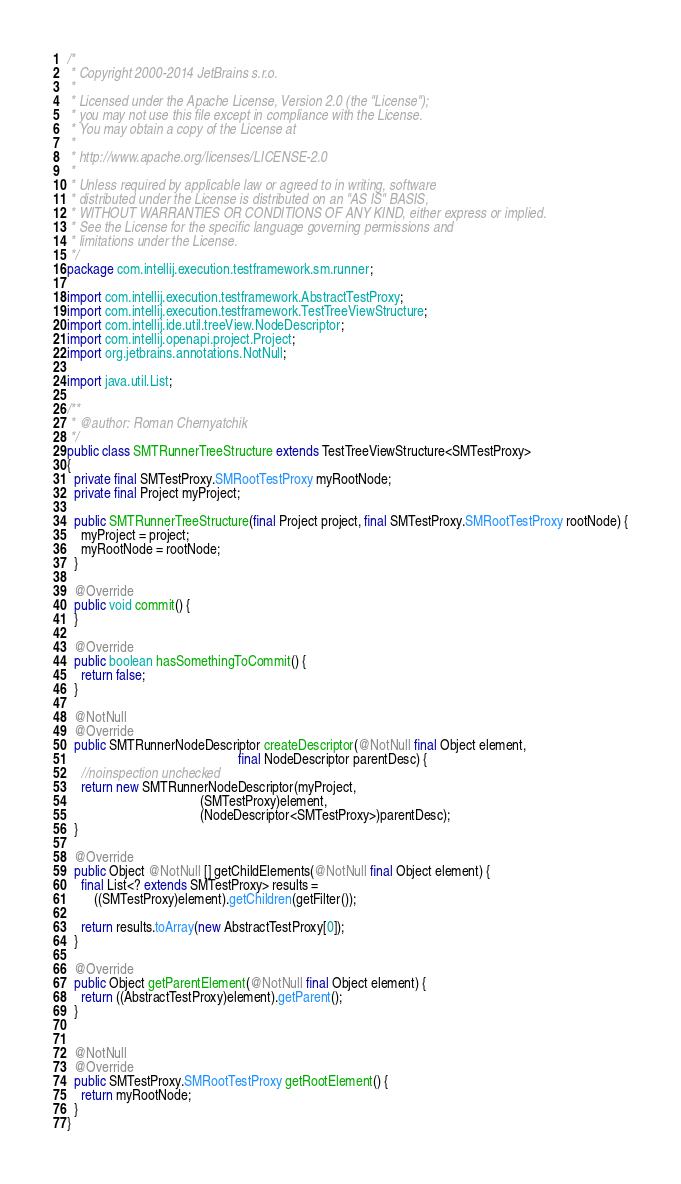<code> <loc_0><loc_0><loc_500><loc_500><_Java_>/*
 * Copyright 2000-2014 JetBrains s.r.o.
 *
 * Licensed under the Apache License, Version 2.0 (the "License");
 * you may not use this file except in compliance with the License.
 * You may obtain a copy of the License at
 *
 * http://www.apache.org/licenses/LICENSE-2.0
 *
 * Unless required by applicable law or agreed to in writing, software
 * distributed under the License is distributed on an "AS IS" BASIS,
 * WITHOUT WARRANTIES OR CONDITIONS OF ANY KIND, either express or implied.
 * See the License for the specific language governing permissions and
 * limitations under the License.
 */
package com.intellij.execution.testframework.sm.runner;

import com.intellij.execution.testframework.AbstractTestProxy;
import com.intellij.execution.testframework.TestTreeViewStructure;
import com.intellij.ide.util.treeView.NodeDescriptor;
import com.intellij.openapi.project.Project;
import org.jetbrains.annotations.NotNull;

import java.util.List;

/**
 * @author: Roman Chernyatchik
 */
public class SMTRunnerTreeStructure extends TestTreeViewStructure<SMTestProxy>
{
  private final SMTestProxy.SMRootTestProxy myRootNode;
  private final Project myProject;

  public SMTRunnerTreeStructure(final Project project, final SMTestProxy.SMRootTestProxy rootNode) {
    myProject = project;
    myRootNode = rootNode;
  }

  @Override
  public void commit() {
  }

  @Override
  public boolean hasSomethingToCommit() {
    return false;
  }

  @NotNull
  @Override
  public SMTRunnerNodeDescriptor createDescriptor(@NotNull final Object element,
                                                  final NodeDescriptor parentDesc) {
    //noinspection unchecked
    return new SMTRunnerNodeDescriptor(myProject,
                                       (SMTestProxy)element,
                                       (NodeDescriptor<SMTestProxy>)parentDesc);
  }

  @Override
  public Object @NotNull [] getChildElements(@NotNull final Object element) {
    final List<? extends SMTestProxy> results =
        ((SMTestProxy)element).getChildren(getFilter());

    return results.toArray(new AbstractTestProxy[0]);
  }

  @Override
  public Object getParentElement(@NotNull final Object element) {
    return ((AbstractTestProxy)element).getParent();
  }


  @NotNull
  @Override
  public SMTestProxy.SMRootTestProxy getRootElement() {
    return myRootNode;
  }
}
</code> 